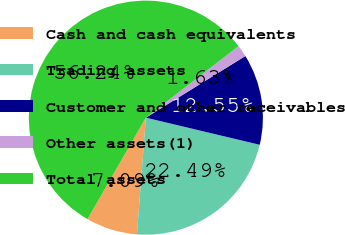<chart> <loc_0><loc_0><loc_500><loc_500><pie_chart><fcel>Cash and cash equivalents<fcel>Trading assets<fcel>Customer and other receivables<fcel>Other assets(1)<fcel>Total assets<nl><fcel>7.09%<fcel>22.49%<fcel>12.55%<fcel>1.63%<fcel>56.24%<nl></chart> 